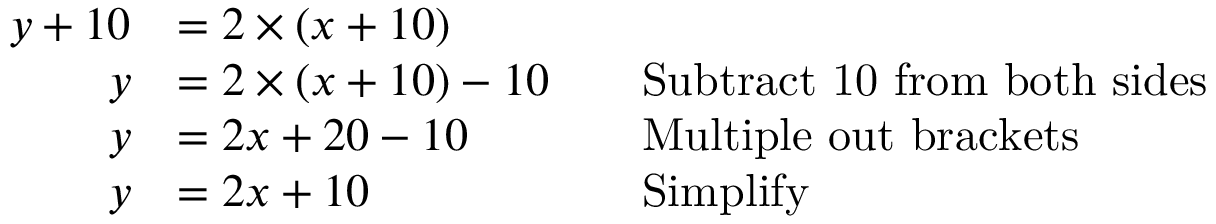Convert formula to latex. <formula><loc_0><loc_0><loc_500><loc_500>{ \begin{array} { r l r l } { y + 1 0 } & { = 2 \times ( x + 1 0 ) } \\ { y } & { = 2 \times ( x + 1 0 ) - 1 0 } & & { S u b t r a c t 1 0 f r o m b o t h s i d e s } \\ { y } & { = 2 x + 2 0 - 1 0 } & & { M u l t i p l e o u t b r a c k e t s } \\ { y } & { = 2 x + 1 0 } & & { S i m p l i f y } \end{array} }</formula> 